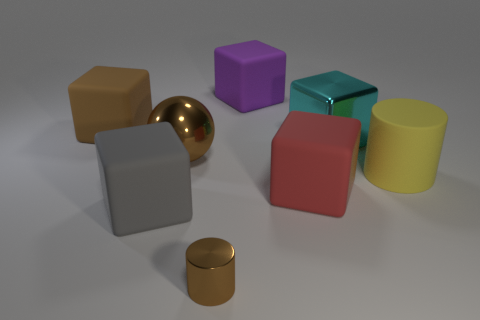What color is the big metallic thing that is right of the brown metallic object behind the big cylinder?
Your response must be concise. Cyan. Is there any other thing that has the same shape as the large brown metallic object?
Your response must be concise. No. Is the number of purple matte objects that are left of the metallic ball the same as the number of purple things that are in front of the cyan object?
Keep it short and to the point. Yes. What number of cylinders are either small brown metallic things or yellow things?
Your answer should be compact. 2. What number of other things are the same material as the large red object?
Ensure brevity in your answer.  4. What is the shape of the brown metallic thing that is on the right side of the brown ball?
Your response must be concise. Cylinder. What is the material of the cylinder left of the cylinder behind the tiny brown cylinder?
Keep it short and to the point. Metal. Is the number of large brown metal balls to the right of the big purple matte cube greater than the number of tiny yellow shiny cylinders?
Offer a very short reply. No. What number of other objects are the same color as the shiny cube?
Give a very brief answer. 0. There is a brown metallic thing that is the same size as the matte cylinder; what shape is it?
Offer a very short reply. Sphere. 